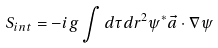<formula> <loc_0><loc_0><loc_500><loc_500>S _ { i n t } = - i g \int d \tau d r ^ { 2 } \psi ^ { * } \vec { a } \cdot \nabla \psi</formula> 